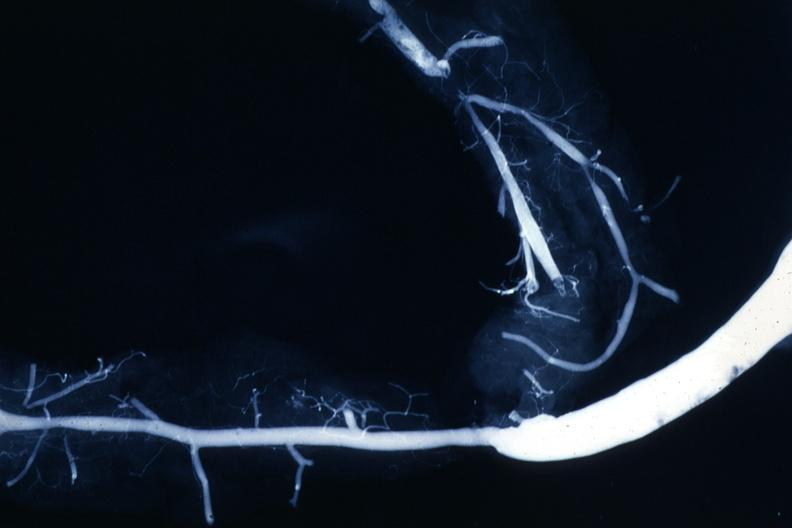where is this from?
Answer the question using a single word or phrase. Heart 